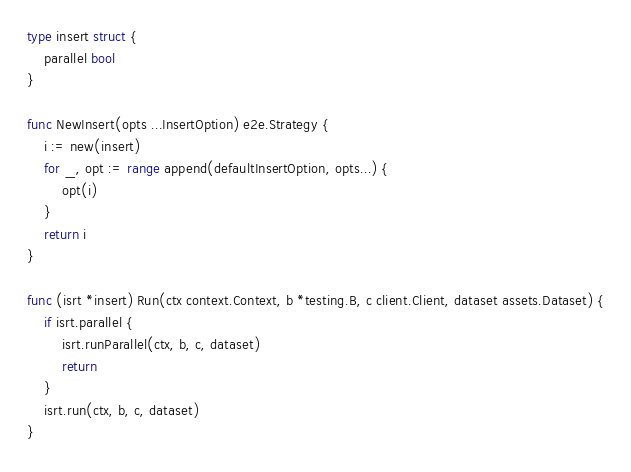<code> <loc_0><loc_0><loc_500><loc_500><_Go_>type insert struct {
	parallel bool
}

func NewInsert(opts ...InsertOption) e2e.Strategy {
	i := new(insert)
	for _, opt := range append(defaultInsertOption, opts...) {
		opt(i)
	}
	return i
}

func (isrt *insert) Run(ctx context.Context, b *testing.B, c client.Client, dataset assets.Dataset) {
	if isrt.parallel {
		isrt.runParallel(ctx, b, c, dataset)
		return
	}
	isrt.run(ctx, b, c, dataset)
}
</code> 